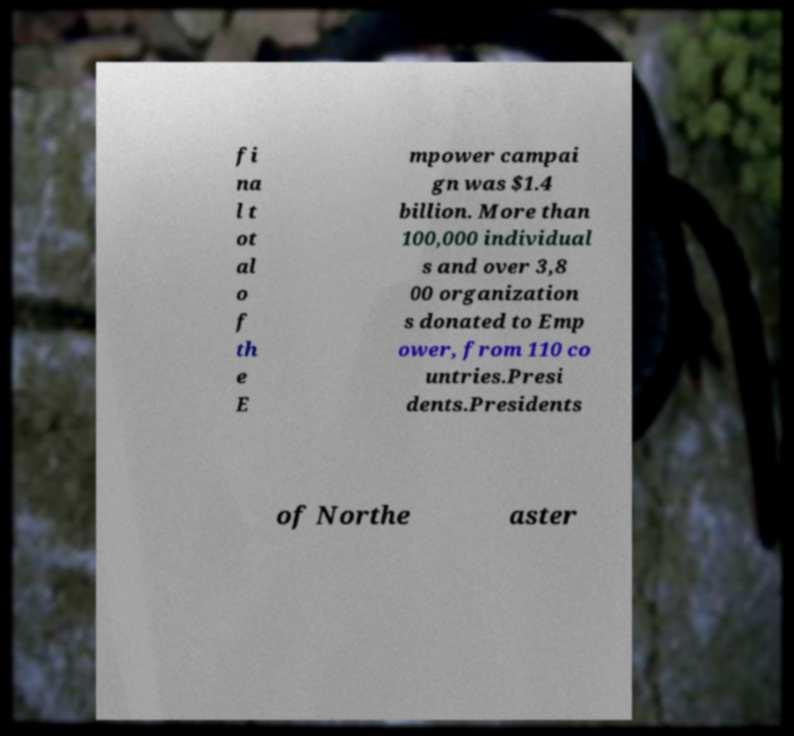Please read and relay the text visible in this image. What does it say? fi na l t ot al o f th e E mpower campai gn was $1.4 billion. More than 100,000 individual s and over 3,8 00 organization s donated to Emp ower, from 110 co untries.Presi dents.Presidents of Northe aster 